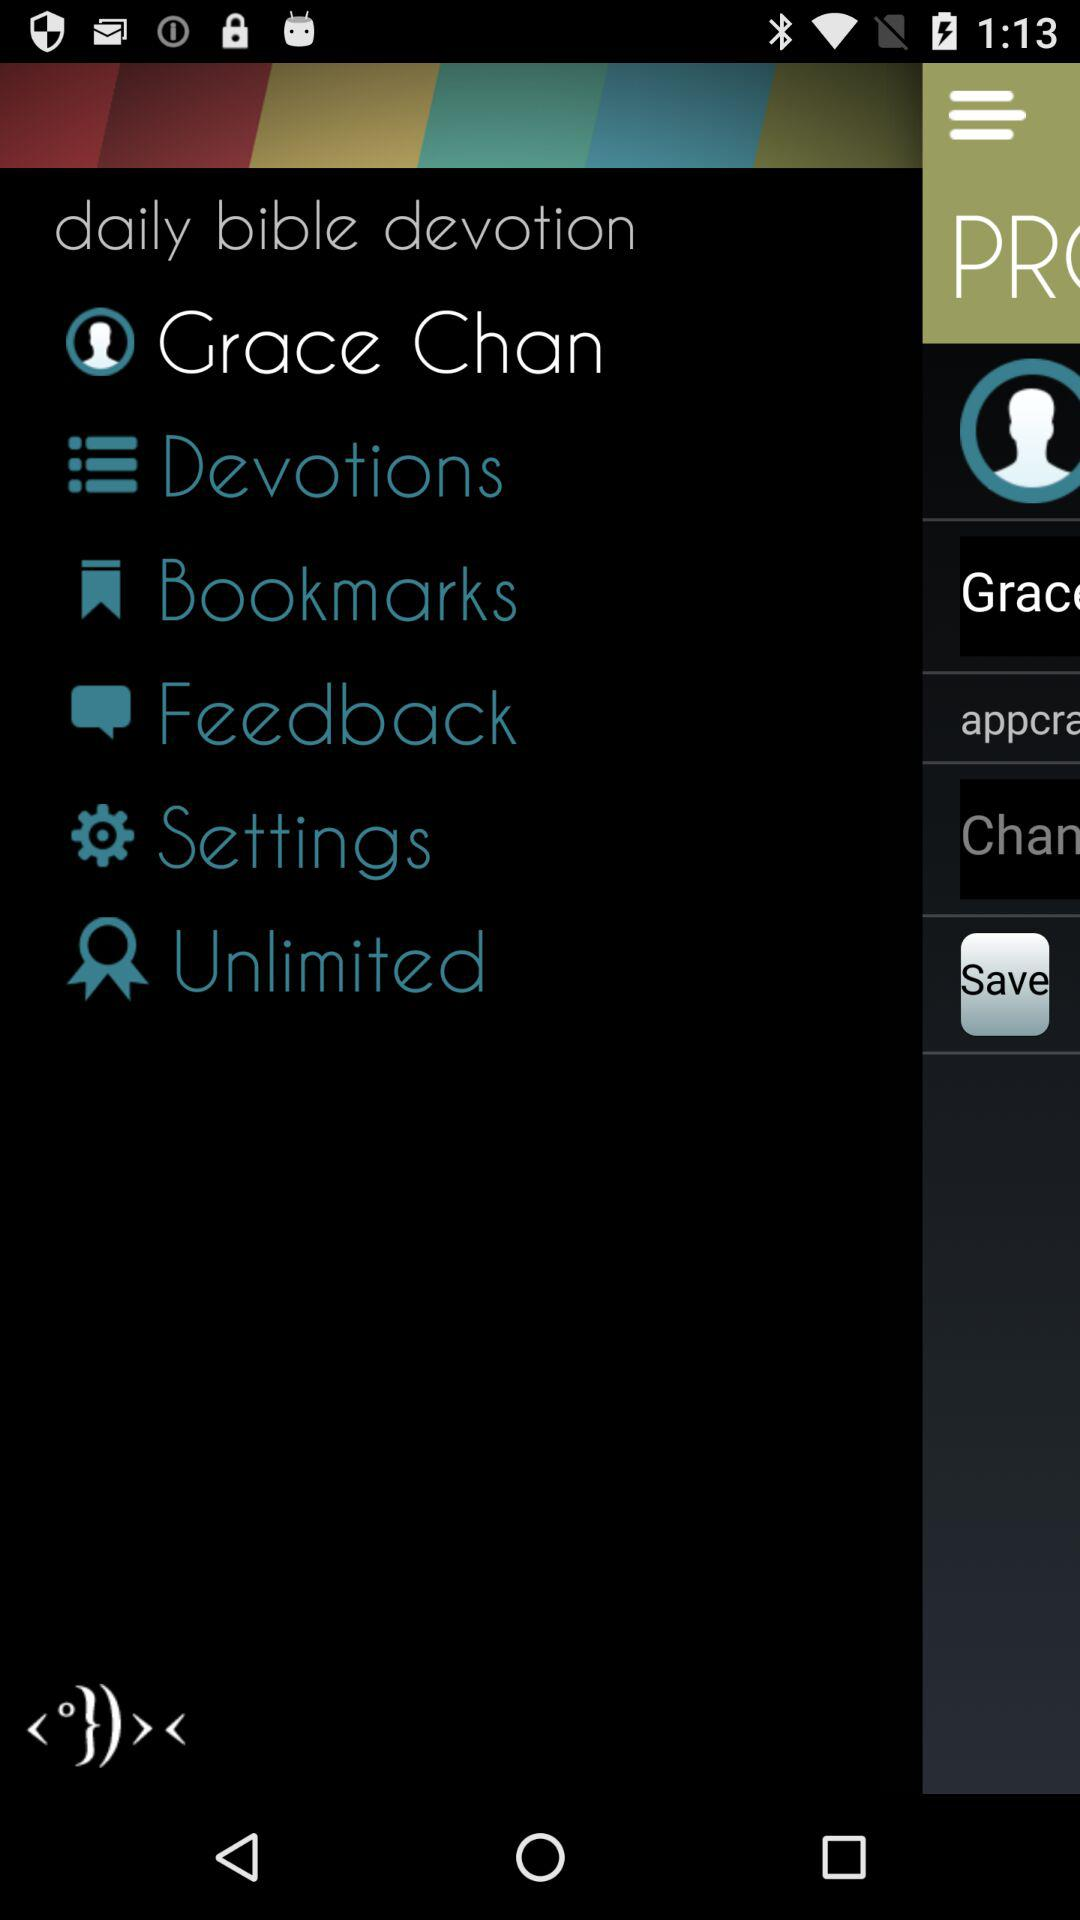What's the user profile name? The user profile name is Grace Chan. 